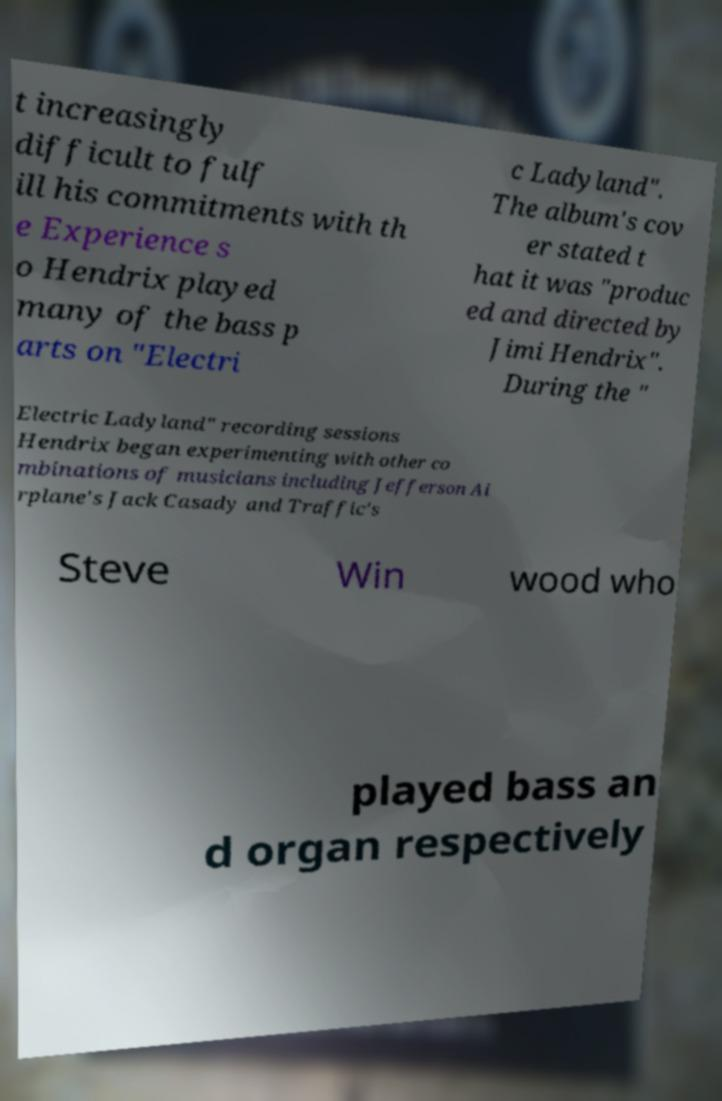I need the written content from this picture converted into text. Can you do that? t increasingly difficult to fulf ill his commitments with th e Experience s o Hendrix played many of the bass p arts on "Electri c Ladyland". The album's cov er stated t hat it was "produc ed and directed by Jimi Hendrix". During the " Electric Ladyland" recording sessions Hendrix began experimenting with other co mbinations of musicians including Jefferson Ai rplane's Jack Casady and Traffic's Steve Win wood who played bass an d organ respectively 